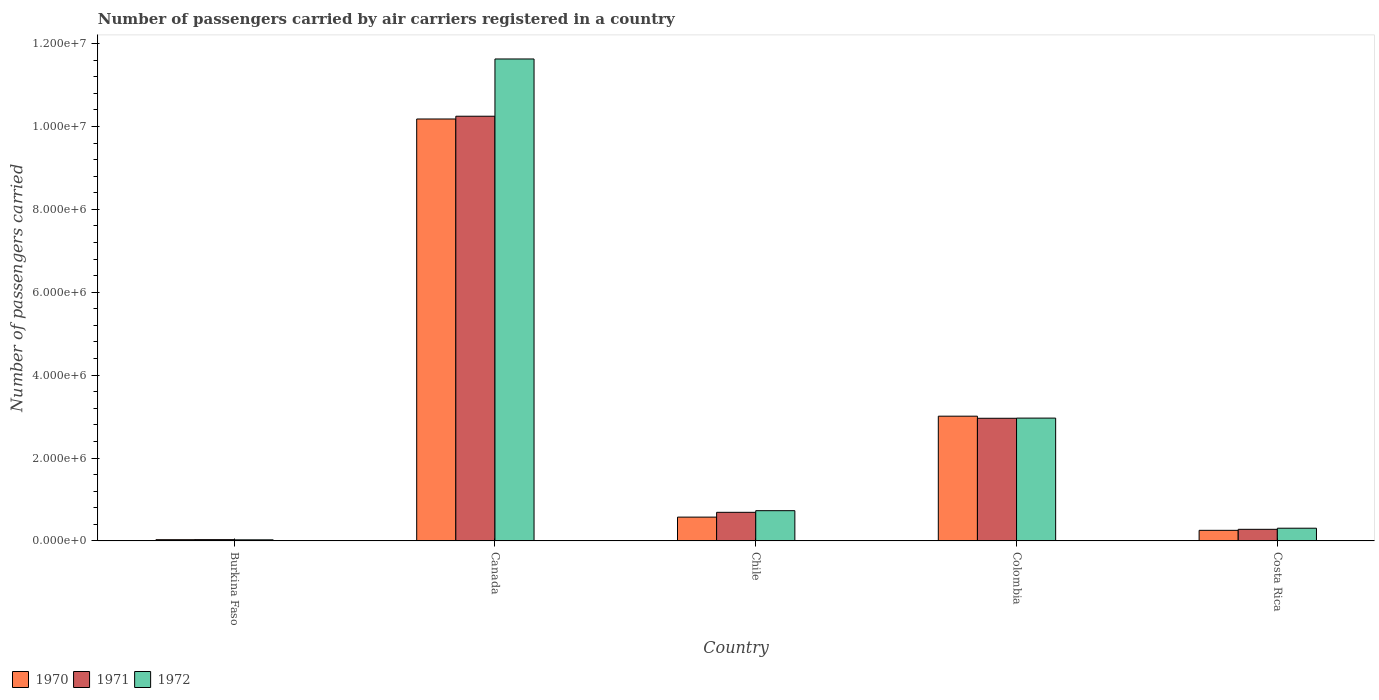How many different coloured bars are there?
Make the answer very short. 3. Are the number of bars per tick equal to the number of legend labels?
Your answer should be compact. Yes. In how many cases, is the number of bars for a given country not equal to the number of legend labels?
Provide a short and direct response. 0. What is the number of passengers carried by air carriers in 1970 in Burkina Faso?
Ensure brevity in your answer.  3.01e+04. Across all countries, what is the maximum number of passengers carried by air carriers in 1971?
Offer a very short reply. 1.02e+07. Across all countries, what is the minimum number of passengers carried by air carriers in 1970?
Your answer should be compact. 3.01e+04. In which country was the number of passengers carried by air carriers in 1972 maximum?
Ensure brevity in your answer.  Canada. In which country was the number of passengers carried by air carriers in 1970 minimum?
Offer a terse response. Burkina Faso. What is the total number of passengers carried by air carriers in 1970 in the graph?
Give a very brief answer. 1.41e+07. What is the difference between the number of passengers carried by air carriers in 1971 in Burkina Faso and that in Chile?
Offer a very short reply. -6.59e+05. What is the difference between the number of passengers carried by air carriers in 1970 in Colombia and the number of passengers carried by air carriers in 1971 in Costa Rica?
Your response must be concise. 2.73e+06. What is the average number of passengers carried by air carriers in 1971 per country?
Your answer should be compact. 2.84e+06. What is the difference between the number of passengers carried by air carriers of/in 1971 and number of passengers carried by air carriers of/in 1972 in Colombia?
Keep it short and to the point. -3900. In how many countries, is the number of passengers carried by air carriers in 1971 greater than 6000000?
Your response must be concise. 1. What is the ratio of the number of passengers carried by air carriers in 1972 in Burkina Faso to that in Canada?
Your response must be concise. 0. Is the number of passengers carried by air carriers in 1970 in Canada less than that in Costa Rica?
Provide a short and direct response. No. Is the difference between the number of passengers carried by air carriers in 1971 in Chile and Colombia greater than the difference between the number of passengers carried by air carriers in 1972 in Chile and Colombia?
Your answer should be very brief. No. What is the difference between the highest and the second highest number of passengers carried by air carriers in 1970?
Ensure brevity in your answer.  -7.17e+06. What is the difference between the highest and the lowest number of passengers carried by air carriers in 1972?
Offer a very short reply. 1.16e+07. In how many countries, is the number of passengers carried by air carriers in 1971 greater than the average number of passengers carried by air carriers in 1971 taken over all countries?
Your answer should be very brief. 2. Is the sum of the number of passengers carried by air carriers in 1970 in Chile and Colombia greater than the maximum number of passengers carried by air carriers in 1972 across all countries?
Make the answer very short. No. What does the 3rd bar from the left in Canada represents?
Provide a short and direct response. 1972. Is it the case that in every country, the sum of the number of passengers carried by air carriers in 1971 and number of passengers carried by air carriers in 1972 is greater than the number of passengers carried by air carriers in 1970?
Offer a very short reply. Yes. How many countries are there in the graph?
Give a very brief answer. 5. Are the values on the major ticks of Y-axis written in scientific E-notation?
Offer a terse response. Yes. Does the graph contain any zero values?
Ensure brevity in your answer.  No. How many legend labels are there?
Provide a succinct answer. 3. How are the legend labels stacked?
Keep it short and to the point. Horizontal. What is the title of the graph?
Offer a very short reply. Number of passengers carried by air carriers registered in a country. Does "1993" appear as one of the legend labels in the graph?
Provide a succinct answer. No. What is the label or title of the Y-axis?
Give a very brief answer. Number of passengers carried. What is the Number of passengers carried in 1970 in Burkina Faso?
Ensure brevity in your answer.  3.01e+04. What is the Number of passengers carried in 1971 in Burkina Faso?
Your response must be concise. 3.16e+04. What is the Number of passengers carried in 1972 in Burkina Faso?
Make the answer very short. 2.65e+04. What is the Number of passengers carried of 1970 in Canada?
Offer a very short reply. 1.02e+07. What is the Number of passengers carried in 1971 in Canada?
Make the answer very short. 1.02e+07. What is the Number of passengers carried in 1972 in Canada?
Make the answer very short. 1.16e+07. What is the Number of passengers carried in 1970 in Chile?
Offer a terse response. 5.75e+05. What is the Number of passengers carried of 1971 in Chile?
Make the answer very short. 6.91e+05. What is the Number of passengers carried in 1972 in Chile?
Provide a short and direct response. 7.30e+05. What is the Number of passengers carried of 1970 in Colombia?
Give a very brief answer. 3.01e+06. What is the Number of passengers carried of 1971 in Colombia?
Ensure brevity in your answer.  2.96e+06. What is the Number of passengers carried in 1972 in Colombia?
Offer a terse response. 2.96e+06. What is the Number of passengers carried of 1970 in Costa Rica?
Provide a short and direct response. 2.56e+05. What is the Number of passengers carried of 1971 in Costa Rica?
Keep it short and to the point. 2.80e+05. What is the Number of passengers carried of 1972 in Costa Rica?
Ensure brevity in your answer.  3.07e+05. Across all countries, what is the maximum Number of passengers carried in 1970?
Offer a terse response. 1.02e+07. Across all countries, what is the maximum Number of passengers carried in 1971?
Offer a terse response. 1.02e+07. Across all countries, what is the maximum Number of passengers carried of 1972?
Make the answer very short. 1.16e+07. Across all countries, what is the minimum Number of passengers carried of 1970?
Offer a terse response. 3.01e+04. Across all countries, what is the minimum Number of passengers carried of 1971?
Offer a terse response. 3.16e+04. Across all countries, what is the minimum Number of passengers carried of 1972?
Make the answer very short. 2.65e+04. What is the total Number of passengers carried of 1970 in the graph?
Your response must be concise. 1.41e+07. What is the total Number of passengers carried of 1971 in the graph?
Make the answer very short. 1.42e+07. What is the total Number of passengers carried in 1972 in the graph?
Keep it short and to the point. 1.57e+07. What is the difference between the Number of passengers carried of 1970 in Burkina Faso and that in Canada?
Your answer should be compact. -1.02e+07. What is the difference between the Number of passengers carried of 1971 in Burkina Faso and that in Canada?
Your answer should be very brief. -1.02e+07. What is the difference between the Number of passengers carried in 1972 in Burkina Faso and that in Canada?
Offer a very short reply. -1.16e+07. What is the difference between the Number of passengers carried in 1970 in Burkina Faso and that in Chile?
Provide a succinct answer. -5.45e+05. What is the difference between the Number of passengers carried in 1971 in Burkina Faso and that in Chile?
Keep it short and to the point. -6.59e+05. What is the difference between the Number of passengers carried of 1972 in Burkina Faso and that in Chile?
Provide a succinct answer. -7.04e+05. What is the difference between the Number of passengers carried in 1970 in Burkina Faso and that in Colombia?
Your response must be concise. -2.98e+06. What is the difference between the Number of passengers carried of 1971 in Burkina Faso and that in Colombia?
Provide a succinct answer. -2.93e+06. What is the difference between the Number of passengers carried of 1972 in Burkina Faso and that in Colombia?
Your response must be concise. -2.94e+06. What is the difference between the Number of passengers carried in 1970 in Burkina Faso and that in Costa Rica?
Make the answer very short. -2.26e+05. What is the difference between the Number of passengers carried of 1971 in Burkina Faso and that in Costa Rica?
Your response must be concise. -2.49e+05. What is the difference between the Number of passengers carried of 1972 in Burkina Faso and that in Costa Rica?
Your answer should be very brief. -2.81e+05. What is the difference between the Number of passengers carried of 1970 in Canada and that in Chile?
Your response must be concise. 9.61e+06. What is the difference between the Number of passengers carried in 1971 in Canada and that in Chile?
Ensure brevity in your answer.  9.56e+06. What is the difference between the Number of passengers carried in 1972 in Canada and that in Chile?
Your answer should be very brief. 1.09e+07. What is the difference between the Number of passengers carried in 1970 in Canada and that in Colombia?
Your answer should be very brief. 7.17e+06. What is the difference between the Number of passengers carried of 1971 in Canada and that in Colombia?
Make the answer very short. 7.29e+06. What is the difference between the Number of passengers carried of 1972 in Canada and that in Colombia?
Your answer should be compact. 8.66e+06. What is the difference between the Number of passengers carried in 1970 in Canada and that in Costa Rica?
Ensure brevity in your answer.  9.92e+06. What is the difference between the Number of passengers carried in 1971 in Canada and that in Costa Rica?
Your response must be concise. 9.97e+06. What is the difference between the Number of passengers carried of 1972 in Canada and that in Costa Rica?
Provide a succinct answer. 1.13e+07. What is the difference between the Number of passengers carried in 1970 in Chile and that in Colombia?
Ensure brevity in your answer.  -2.44e+06. What is the difference between the Number of passengers carried in 1971 in Chile and that in Colombia?
Keep it short and to the point. -2.27e+06. What is the difference between the Number of passengers carried in 1972 in Chile and that in Colombia?
Provide a short and direct response. -2.23e+06. What is the difference between the Number of passengers carried in 1970 in Chile and that in Costa Rica?
Give a very brief answer. 3.19e+05. What is the difference between the Number of passengers carried of 1971 in Chile and that in Costa Rica?
Offer a very short reply. 4.10e+05. What is the difference between the Number of passengers carried of 1972 in Chile and that in Costa Rica?
Ensure brevity in your answer.  4.23e+05. What is the difference between the Number of passengers carried in 1970 in Colombia and that in Costa Rica?
Provide a short and direct response. 2.75e+06. What is the difference between the Number of passengers carried of 1971 in Colombia and that in Costa Rica?
Your answer should be compact. 2.68e+06. What is the difference between the Number of passengers carried in 1972 in Colombia and that in Costa Rica?
Give a very brief answer. 2.66e+06. What is the difference between the Number of passengers carried in 1970 in Burkina Faso and the Number of passengers carried in 1971 in Canada?
Give a very brief answer. -1.02e+07. What is the difference between the Number of passengers carried of 1970 in Burkina Faso and the Number of passengers carried of 1972 in Canada?
Keep it short and to the point. -1.16e+07. What is the difference between the Number of passengers carried of 1971 in Burkina Faso and the Number of passengers carried of 1972 in Canada?
Your response must be concise. -1.16e+07. What is the difference between the Number of passengers carried of 1970 in Burkina Faso and the Number of passengers carried of 1971 in Chile?
Your answer should be compact. -6.60e+05. What is the difference between the Number of passengers carried of 1970 in Burkina Faso and the Number of passengers carried of 1972 in Chile?
Your response must be concise. -7.00e+05. What is the difference between the Number of passengers carried of 1971 in Burkina Faso and the Number of passengers carried of 1972 in Chile?
Your response must be concise. -6.98e+05. What is the difference between the Number of passengers carried in 1970 in Burkina Faso and the Number of passengers carried in 1971 in Colombia?
Give a very brief answer. -2.93e+06. What is the difference between the Number of passengers carried in 1970 in Burkina Faso and the Number of passengers carried in 1972 in Colombia?
Make the answer very short. -2.93e+06. What is the difference between the Number of passengers carried in 1971 in Burkina Faso and the Number of passengers carried in 1972 in Colombia?
Provide a succinct answer. -2.93e+06. What is the difference between the Number of passengers carried of 1970 in Burkina Faso and the Number of passengers carried of 1971 in Costa Rica?
Give a very brief answer. -2.50e+05. What is the difference between the Number of passengers carried of 1970 in Burkina Faso and the Number of passengers carried of 1972 in Costa Rica?
Keep it short and to the point. -2.77e+05. What is the difference between the Number of passengers carried in 1971 in Burkina Faso and the Number of passengers carried in 1972 in Costa Rica?
Offer a terse response. -2.76e+05. What is the difference between the Number of passengers carried of 1970 in Canada and the Number of passengers carried of 1971 in Chile?
Offer a terse response. 9.49e+06. What is the difference between the Number of passengers carried in 1970 in Canada and the Number of passengers carried in 1972 in Chile?
Offer a terse response. 9.45e+06. What is the difference between the Number of passengers carried of 1971 in Canada and the Number of passengers carried of 1972 in Chile?
Provide a succinct answer. 9.52e+06. What is the difference between the Number of passengers carried of 1970 in Canada and the Number of passengers carried of 1971 in Colombia?
Ensure brevity in your answer.  7.22e+06. What is the difference between the Number of passengers carried in 1970 in Canada and the Number of passengers carried in 1972 in Colombia?
Offer a very short reply. 7.22e+06. What is the difference between the Number of passengers carried of 1971 in Canada and the Number of passengers carried of 1972 in Colombia?
Offer a terse response. 7.28e+06. What is the difference between the Number of passengers carried in 1970 in Canada and the Number of passengers carried in 1971 in Costa Rica?
Make the answer very short. 9.90e+06. What is the difference between the Number of passengers carried of 1970 in Canada and the Number of passengers carried of 1972 in Costa Rica?
Offer a very short reply. 9.87e+06. What is the difference between the Number of passengers carried of 1971 in Canada and the Number of passengers carried of 1972 in Costa Rica?
Offer a terse response. 9.94e+06. What is the difference between the Number of passengers carried of 1970 in Chile and the Number of passengers carried of 1971 in Colombia?
Your answer should be very brief. -2.38e+06. What is the difference between the Number of passengers carried in 1970 in Chile and the Number of passengers carried in 1972 in Colombia?
Ensure brevity in your answer.  -2.39e+06. What is the difference between the Number of passengers carried in 1971 in Chile and the Number of passengers carried in 1972 in Colombia?
Ensure brevity in your answer.  -2.27e+06. What is the difference between the Number of passengers carried of 1970 in Chile and the Number of passengers carried of 1971 in Costa Rica?
Your answer should be very brief. 2.94e+05. What is the difference between the Number of passengers carried in 1970 in Chile and the Number of passengers carried in 1972 in Costa Rica?
Offer a very short reply. 2.67e+05. What is the difference between the Number of passengers carried of 1971 in Chile and the Number of passengers carried of 1972 in Costa Rica?
Keep it short and to the point. 3.83e+05. What is the difference between the Number of passengers carried of 1970 in Colombia and the Number of passengers carried of 1971 in Costa Rica?
Your response must be concise. 2.73e+06. What is the difference between the Number of passengers carried of 1970 in Colombia and the Number of passengers carried of 1972 in Costa Rica?
Keep it short and to the point. 2.70e+06. What is the difference between the Number of passengers carried of 1971 in Colombia and the Number of passengers carried of 1972 in Costa Rica?
Keep it short and to the point. 2.65e+06. What is the average Number of passengers carried in 1970 per country?
Your response must be concise. 2.81e+06. What is the average Number of passengers carried of 1971 per country?
Provide a succinct answer. 2.84e+06. What is the average Number of passengers carried in 1972 per country?
Ensure brevity in your answer.  3.13e+06. What is the difference between the Number of passengers carried in 1970 and Number of passengers carried in 1971 in Burkina Faso?
Give a very brief answer. -1500. What is the difference between the Number of passengers carried in 1970 and Number of passengers carried in 1972 in Burkina Faso?
Give a very brief answer. 3600. What is the difference between the Number of passengers carried of 1971 and Number of passengers carried of 1972 in Burkina Faso?
Offer a terse response. 5100. What is the difference between the Number of passengers carried in 1970 and Number of passengers carried in 1971 in Canada?
Offer a very short reply. -6.70e+04. What is the difference between the Number of passengers carried of 1970 and Number of passengers carried of 1972 in Canada?
Keep it short and to the point. -1.45e+06. What is the difference between the Number of passengers carried in 1971 and Number of passengers carried in 1972 in Canada?
Your response must be concise. -1.38e+06. What is the difference between the Number of passengers carried in 1970 and Number of passengers carried in 1971 in Chile?
Offer a very short reply. -1.16e+05. What is the difference between the Number of passengers carried of 1970 and Number of passengers carried of 1972 in Chile?
Keep it short and to the point. -1.55e+05. What is the difference between the Number of passengers carried of 1971 and Number of passengers carried of 1972 in Chile?
Offer a terse response. -3.94e+04. What is the difference between the Number of passengers carried of 1970 and Number of passengers carried of 1971 in Colombia?
Provide a succinct answer. 5.05e+04. What is the difference between the Number of passengers carried of 1970 and Number of passengers carried of 1972 in Colombia?
Keep it short and to the point. 4.66e+04. What is the difference between the Number of passengers carried in 1971 and Number of passengers carried in 1972 in Colombia?
Make the answer very short. -3900. What is the difference between the Number of passengers carried of 1970 and Number of passengers carried of 1971 in Costa Rica?
Offer a terse response. -2.45e+04. What is the difference between the Number of passengers carried in 1970 and Number of passengers carried in 1972 in Costa Rica?
Make the answer very short. -5.14e+04. What is the difference between the Number of passengers carried of 1971 and Number of passengers carried of 1972 in Costa Rica?
Give a very brief answer. -2.69e+04. What is the ratio of the Number of passengers carried in 1970 in Burkina Faso to that in Canada?
Offer a very short reply. 0. What is the ratio of the Number of passengers carried of 1971 in Burkina Faso to that in Canada?
Offer a very short reply. 0. What is the ratio of the Number of passengers carried of 1972 in Burkina Faso to that in Canada?
Provide a succinct answer. 0. What is the ratio of the Number of passengers carried of 1970 in Burkina Faso to that in Chile?
Offer a very short reply. 0.05. What is the ratio of the Number of passengers carried in 1971 in Burkina Faso to that in Chile?
Your answer should be compact. 0.05. What is the ratio of the Number of passengers carried of 1972 in Burkina Faso to that in Chile?
Your answer should be very brief. 0.04. What is the ratio of the Number of passengers carried of 1970 in Burkina Faso to that in Colombia?
Make the answer very short. 0.01. What is the ratio of the Number of passengers carried of 1971 in Burkina Faso to that in Colombia?
Ensure brevity in your answer.  0.01. What is the ratio of the Number of passengers carried of 1972 in Burkina Faso to that in Colombia?
Offer a terse response. 0.01. What is the ratio of the Number of passengers carried in 1970 in Burkina Faso to that in Costa Rica?
Ensure brevity in your answer.  0.12. What is the ratio of the Number of passengers carried in 1971 in Burkina Faso to that in Costa Rica?
Make the answer very short. 0.11. What is the ratio of the Number of passengers carried in 1972 in Burkina Faso to that in Costa Rica?
Your answer should be compact. 0.09. What is the ratio of the Number of passengers carried in 1970 in Canada to that in Chile?
Offer a very short reply. 17.71. What is the ratio of the Number of passengers carried in 1971 in Canada to that in Chile?
Offer a terse response. 14.84. What is the ratio of the Number of passengers carried in 1972 in Canada to that in Chile?
Your answer should be very brief. 15.93. What is the ratio of the Number of passengers carried of 1970 in Canada to that in Colombia?
Offer a terse response. 3.38. What is the ratio of the Number of passengers carried in 1971 in Canada to that in Colombia?
Offer a terse response. 3.46. What is the ratio of the Number of passengers carried of 1972 in Canada to that in Colombia?
Provide a succinct answer. 3.92. What is the ratio of the Number of passengers carried in 1970 in Canada to that in Costa Rica?
Offer a terse response. 39.78. What is the ratio of the Number of passengers carried in 1971 in Canada to that in Costa Rica?
Make the answer very short. 36.55. What is the ratio of the Number of passengers carried in 1972 in Canada to that in Costa Rica?
Provide a short and direct response. 37.84. What is the ratio of the Number of passengers carried in 1970 in Chile to that in Colombia?
Keep it short and to the point. 0.19. What is the ratio of the Number of passengers carried of 1971 in Chile to that in Colombia?
Provide a short and direct response. 0.23. What is the ratio of the Number of passengers carried of 1972 in Chile to that in Colombia?
Your response must be concise. 0.25. What is the ratio of the Number of passengers carried of 1970 in Chile to that in Costa Rica?
Ensure brevity in your answer.  2.25. What is the ratio of the Number of passengers carried in 1971 in Chile to that in Costa Rica?
Give a very brief answer. 2.46. What is the ratio of the Number of passengers carried of 1972 in Chile to that in Costa Rica?
Your response must be concise. 2.38. What is the ratio of the Number of passengers carried of 1970 in Colombia to that in Costa Rica?
Keep it short and to the point. 11.76. What is the ratio of the Number of passengers carried in 1971 in Colombia to that in Costa Rica?
Provide a succinct answer. 10.56. What is the ratio of the Number of passengers carried in 1972 in Colombia to that in Costa Rica?
Keep it short and to the point. 9.64. What is the difference between the highest and the second highest Number of passengers carried in 1970?
Keep it short and to the point. 7.17e+06. What is the difference between the highest and the second highest Number of passengers carried in 1971?
Offer a very short reply. 7.29e+06. What is the difference between the highest and the second highest Number of passengers carried in 1972?
Provide a succinct answer. 8.66e+06. What is the difference between the highest and the lowest Number of passengers carried in 1970?
Provide a succinct answer. 1.02e+07. What is the difference between the highest and the lowest Number of passengers carried of 1971?
Make the answer very short. 1.02e+07. What is the difference between the highest and the lowest Number of passengers carried in 1972?
Keep it short and to the point. 1.16e+07. 